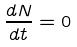Convert formula to latex. <formula><loc_0><loc_0><loc_500><loc_500>\frac { d N } { d t } = 0</formula> 